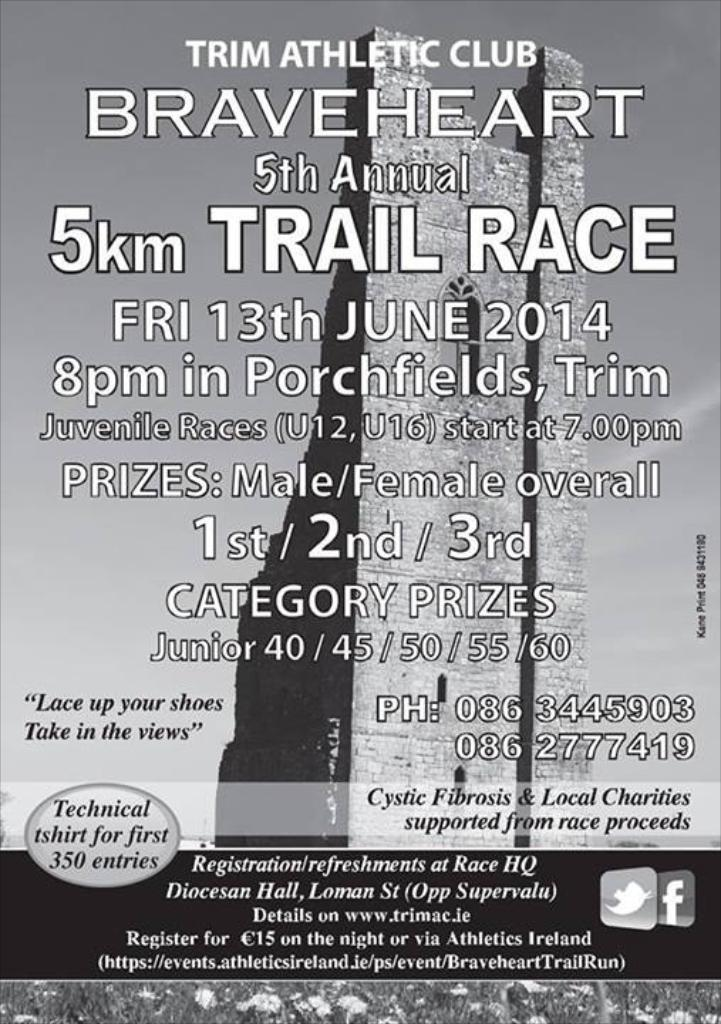<image>
Give a short and clear explanation of the subsequent image. The Trim Athletic Club sponsored the fifth annual 5km Trail Race on June 13, 2014. 